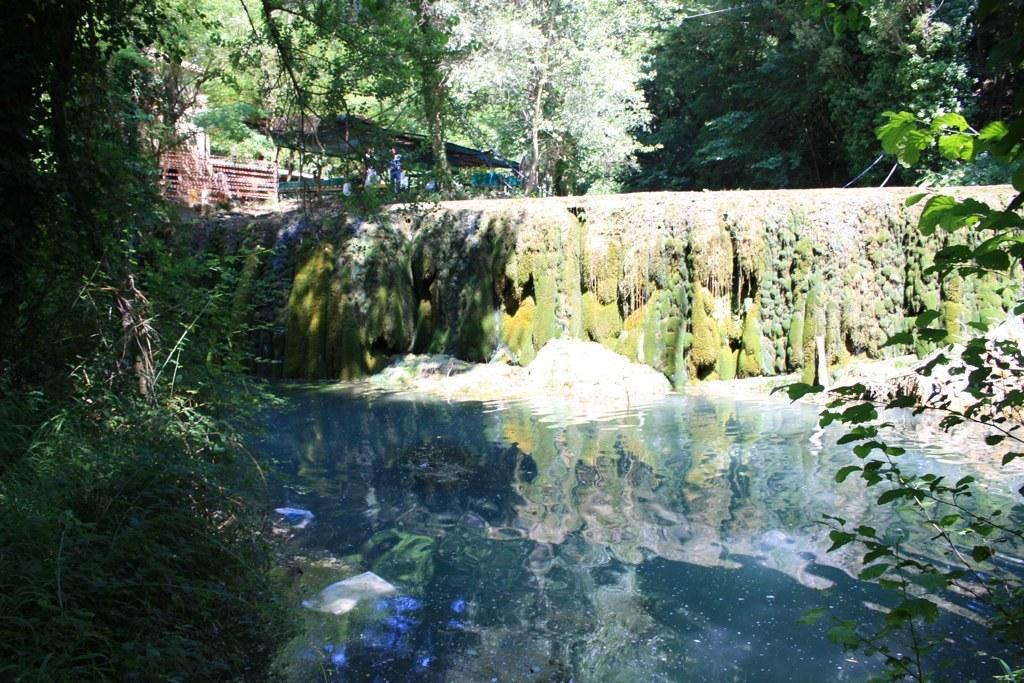Please provide a concise description of this image. An outdoor picture. This is a freshwater river. There are number of trees. Far there is a tent. 